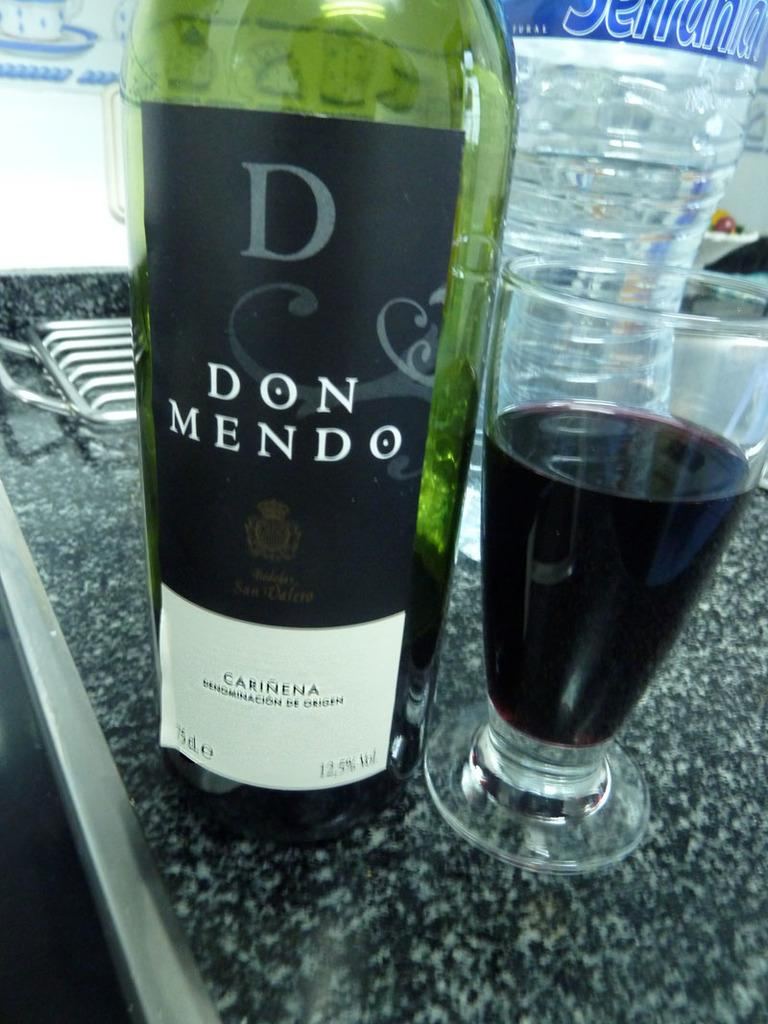What type of beverages are featured in the image? There is a wine bottle and a water bottle in the image. What is the wine bottle's contents being served in? There is a glass of wine in the image. What type of cloth is draped over the wine bottle in the image? There is no cloth present on the wine bottle in the image. What type of growth can be seen on the water bottle in the image? There is no growth present on the water bottle in the image. 